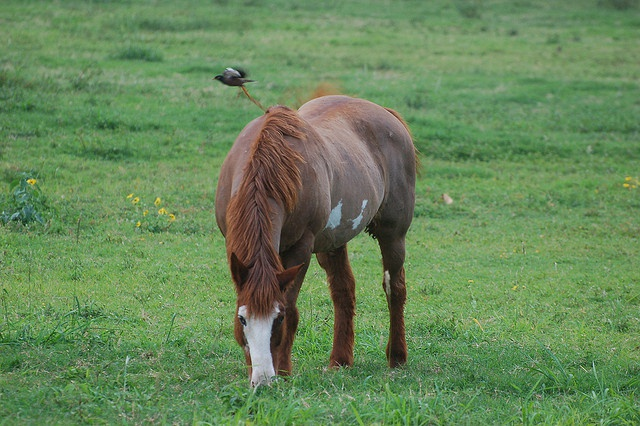Describe the objects in this image and their specific colors. I can see horse in green, gray, black, maroon, and darkgray tones and bird in green, black, gray, and darkgray tones in this image. 